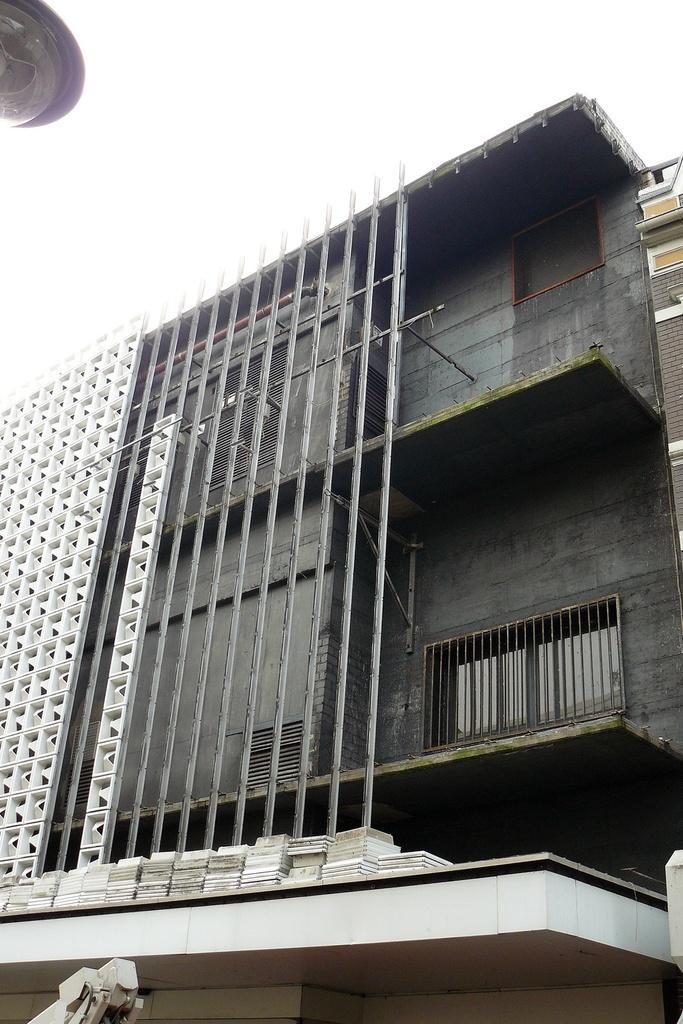Could you give a brief overview of what you see in this image? We can see building,light and sky. 